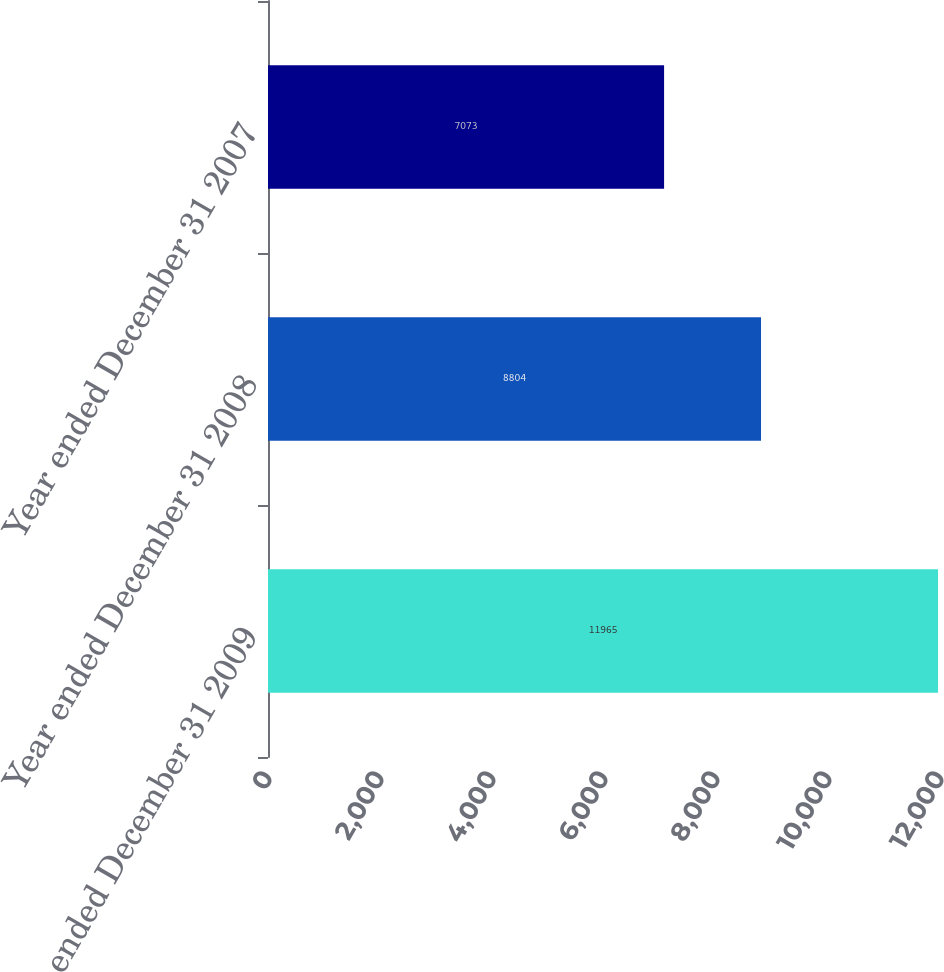Convert chart. <chart><loc_0><loc_0><loc_500><loc_500><bar_chart><fcel>Year ended December 31 2009<fcel>Year ended December 31 2008<fcel>Year ended December 31 2007<nl><fcel>11965<fcel>8804<fcel>7073<nl></chart> 